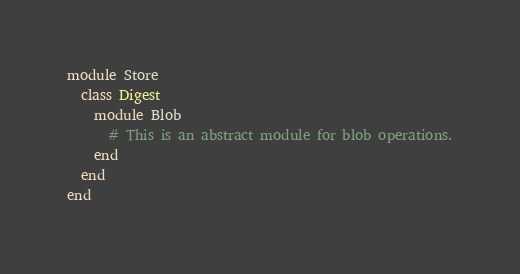Convert code to text. <code><loc_0><loc_0><loc_500><loc_500><_Ruby_>module Store
  class Digest
    module Blob
      # This is an abstract module for blob operations.
    end
  end
end
</code> 